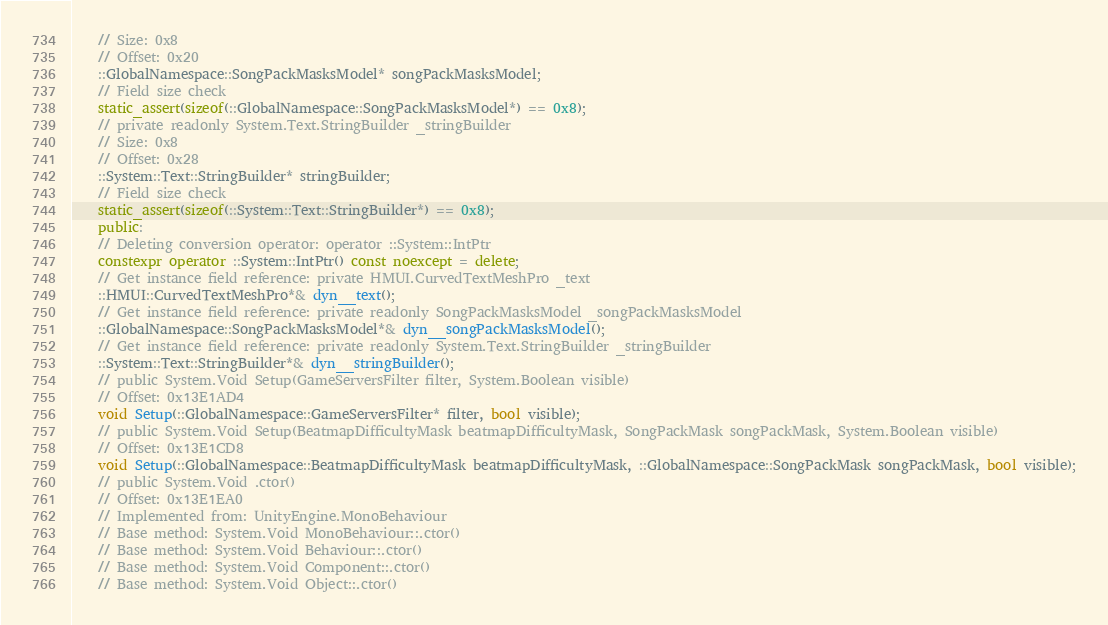Convert code to text. <code><loc_0><loc_0><loc_500><loc_500><_C++_>    // Size: 0x8
    // Offset: 0x20
    ::GlobalNamespace::SongPackMasksModel* songPackMasksModel;
    // Field size check
    static_assert(sizeof(::GlobalNamespace::SongPackMasksModel*) == 0x8);
    // private readonly System.Text.StringBuilder _stringBuilder
    // Size: 0x8
    // Offset: 0x28
    ::System::Text::StringBuilder* stringBuilder;
    // Field size check
    static_assert(sizeof(::System::Text::StringBuilder*) == 0x8);
    public:
    // Deleting conversion operator: operator ::System::IntPtr
    constexpr operator ::System::IntPtr() const noexcept = delete;
    // Get instance field reference: private HMUI.CurvedTextMeshPro _text
    ::HMUI::CurvedTextMeshPro*& dyn__text();
    // Get instance field reference: private readonly SongPackMasksModel _songPackMasksModel
    ::GlobalNamespace::SongPackMasksModel*& dyn__songPackMasksModel();
    // Get instance field reference: private readonly System.Text.StringBuilder _stringBuilder
    ::System::Text::StringBuilder*& dyn__stringBuilder();
    // public System.Void Setup(GameServersFilter filter, System.Boolean visible)
    // Offset: 0x13E1AD4
    void Setup(::GlobalNamespace::GameServersFilter* filter, bool visible);
    // public System.Void Setup(BeatmapDifficultyMask beatmapDifficultyMask, SongPackMask songPackMask, System.Boolean visible)
    // Offset: 0x13E1CD8
    void Setup(::GlobalNamespace::BeatmapDifficultyMask beatmapDifficultyMask, ::GlobalNamespace::SongPackMask songPackMask, bool visible);
    // public System.Void .ctor()
    // Offset: 0x13E1EA0
    // Implemented from: UnityEngine.MonoBehaviour
    // Base method: System.Void MonoBehaviour::.ctor()
    // Base method: System.Void Behaviour::.ctor()
    // Base method: System.Void Component::.ctor()
    // Base method: System.Void Object::.ctor()</code> 